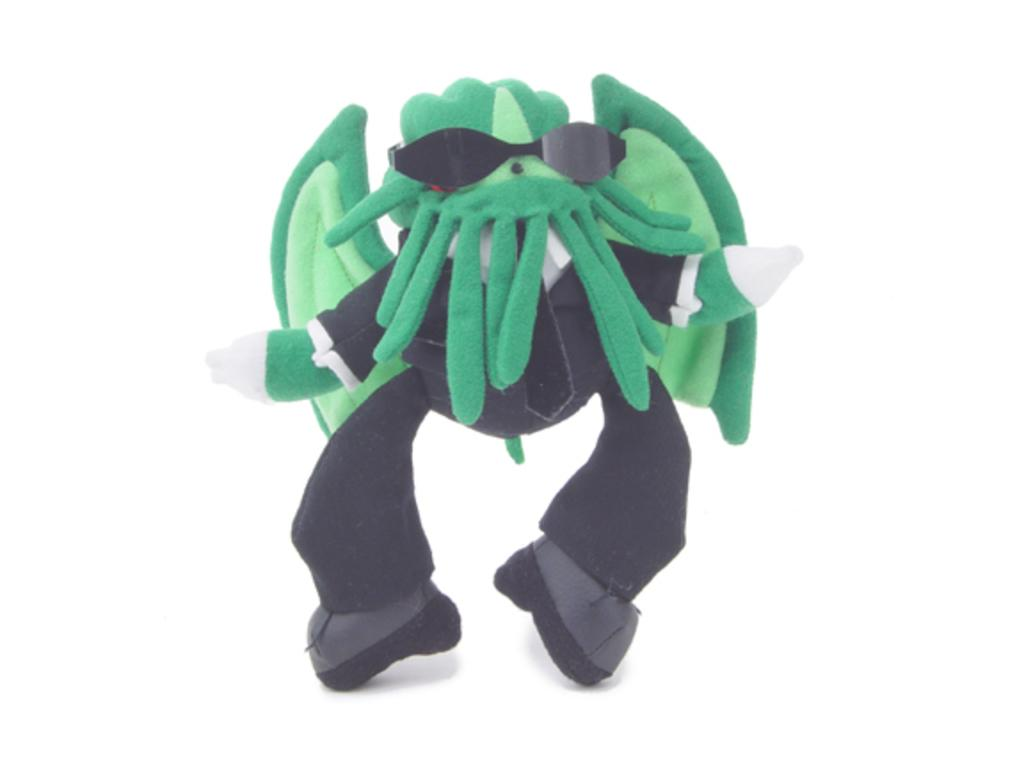What object can be seen in the image? There is a toy in the image. How many men are sitting on the sofa in the image? There is no sofa or men present in the image; it only features a toy. 